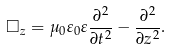<formula> <loc_0><loc_0><loc_500><loc_500>\square _ { z } = \mu _ { 0 } \varepsilon _ { 0 } \varepsilon \frac { \partial ^ { 2 } } { \partial t ^ { 2 } } - \frac { \partial ^ { 2 } } { \partial z ^ { 2 } } .</formula> 